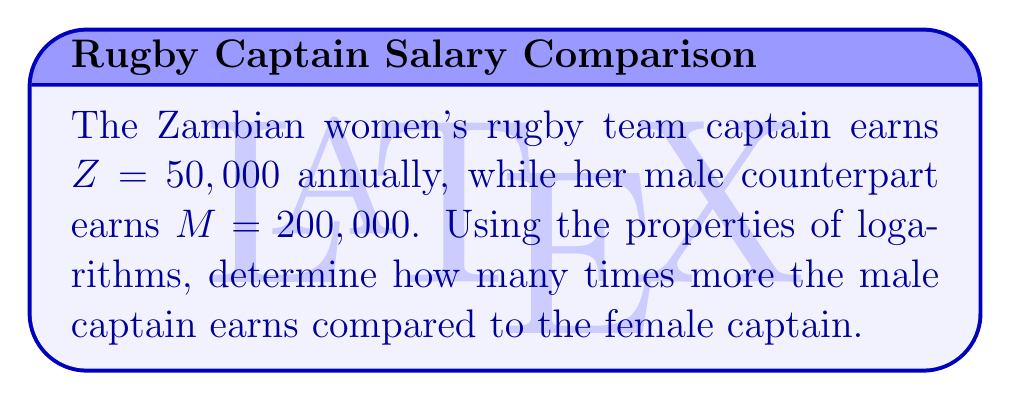Help me with this question. To compare the earnings using logarithms, we'll follow these steps:

1) Let $x$ represent how many times more the male captain earns. This means:

   $M = xZ$

2) Substituting the given values:

   $200,000 = x(50,000)$

3) To solve this using logarithms, we'll take the log of both sides:

   $\log(200,000) = \log(x(50,000))$

4) Using the logarithm property $\log(ab) = \log(a) + \log(b)$:

   $\log(200,000) = \log(x) + \log(50,000)$

5) Subtract $\log(50,000)$ from both sides:

   $\log(200,000) - \log(50,000) = \log(x)$

6) Using the logarithm property $\log(a) - \log(b) = \log(\frac{a}{b})$:

   $\log(\frac{200,000}{50,000}) = \log(x)$

7) Simplify inside the parentheses:

   $\log(4) = \log(x)$

8) Since the logarithms are equal, their arguments must be equal:

   $x = 4$

Therefore, the male captain earns 4 times more than the female captain.
Answer: 4 times 